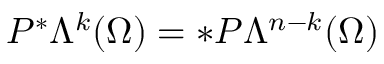Convert formula to latex. <formula><loc_0><loc_0><loc_500><loc_500>P ^ { \ast } \Lambda ^ { k } ( \Omega ) = \ast P \Lambda ^ { n - k } ( \Omega )</formula> 